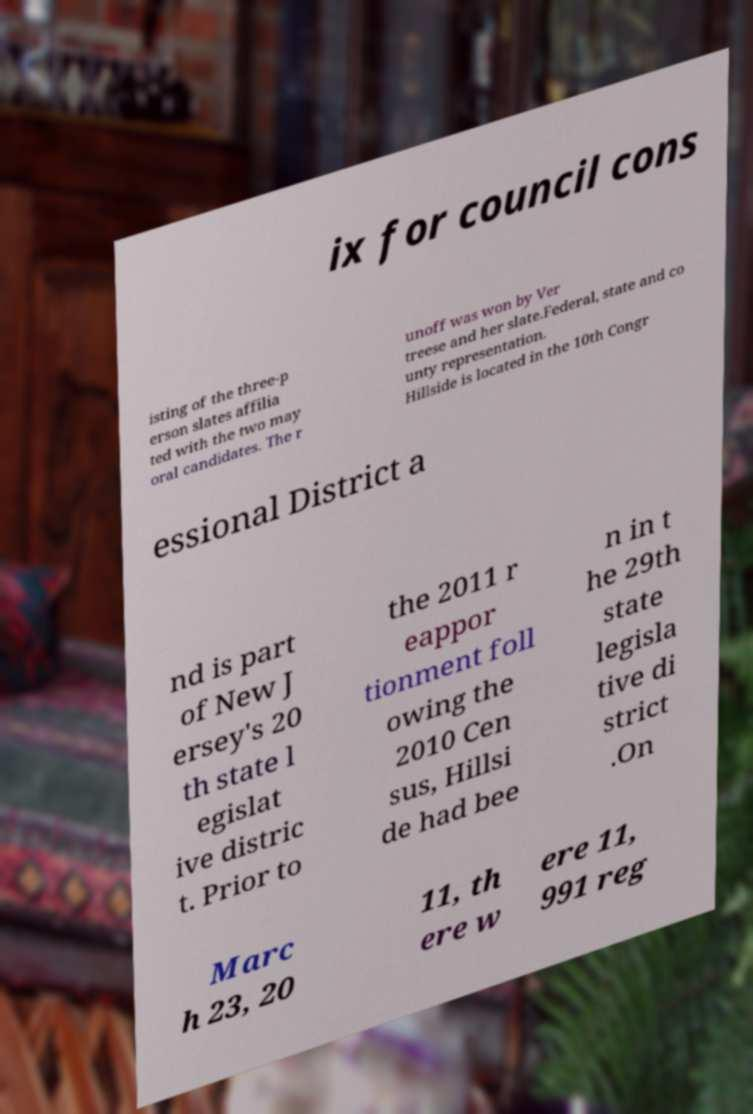Can you read and provide the text displayed in the image?This photo seems to have some interesting text. Can you extract and type it out for me? ix for council cons isting of the three-p erson slates affilia ted with the two may oral candidates. The r unoff was won by Ver treese and her slate.Federal, state and co unty representation. Hillside is located in the 10th Congr essional District a nd is part of New J ersey's 20 th state l egislat ive distric t. Prior to the 2011 r eappor tionment foll owing the 2010 Cen sus, Hillsi de had bee n in t he 29th state legisla tive di strict .On Marc h 23, 20 11, th ere w ere 11, 991 reg 